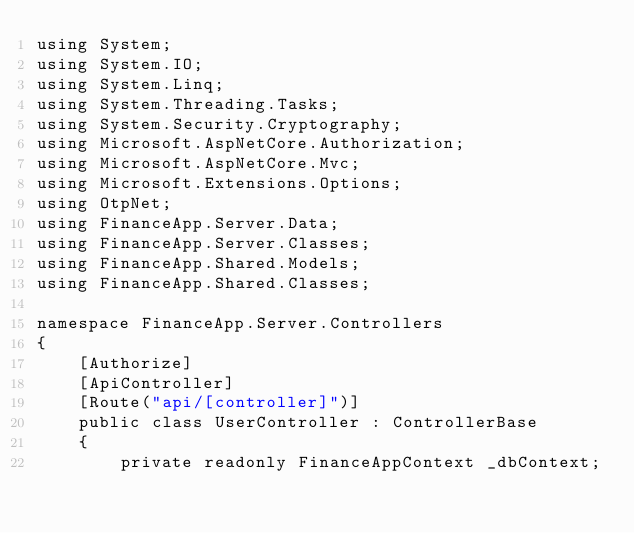<code> <loc_0><loc_0><loc_500><loc_500><_C#_>using System;
using System.IO;
using System.Linq;
using System.Threading.Tasks;
using System.Security.Cryptography;
using Microsoft.AspNetCore.Authorization;
using Microsoft.AspNetCore.Mvc;
using Microsoft.Extensions.Options;
using OtpNet;
using FinanceApp.Server.Data;
using FinanceApp.Server.Classes;
using FinanceApp.Shared.Models;
using FinanceApp.Shared.Classes;

namespace FinanceApp.Server.Controllers
{
    [Authorize]
    [ApiController]
    [Route("api/[controller]")]
    public class UserController : ControllerBase
    {
        private readonly FinanceAppContext _dbContext;
</code> 